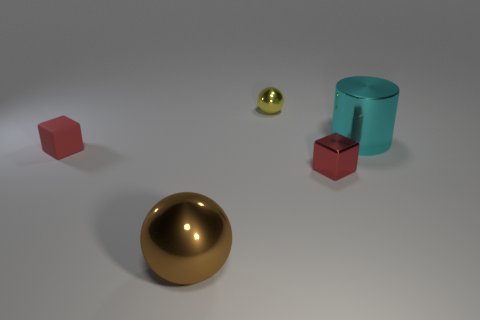Subtract all balls. How many objects are left? 3 Add 5 small purple metal cylinders. How many objects exist? 10 Subtract 1 cylinders. How many cylinders are left? 0 Add 5 metal cylinders. How many metal cylinders are left? 6 Add 1 large brown things. How many large brown things exist? 2 Subtract all brown balls. How many balls are left? 1 Subtract 0 red cylinders. How many objects are left? 5 Subtract all green spheres. Subtract all blue cylinders. How many spheres are left? 2 Subtract all brown blocks. How many cyan spheres are left? 0 Subtract all red blocks. Subtract all large green rubber balls. How many objects are left? 3 